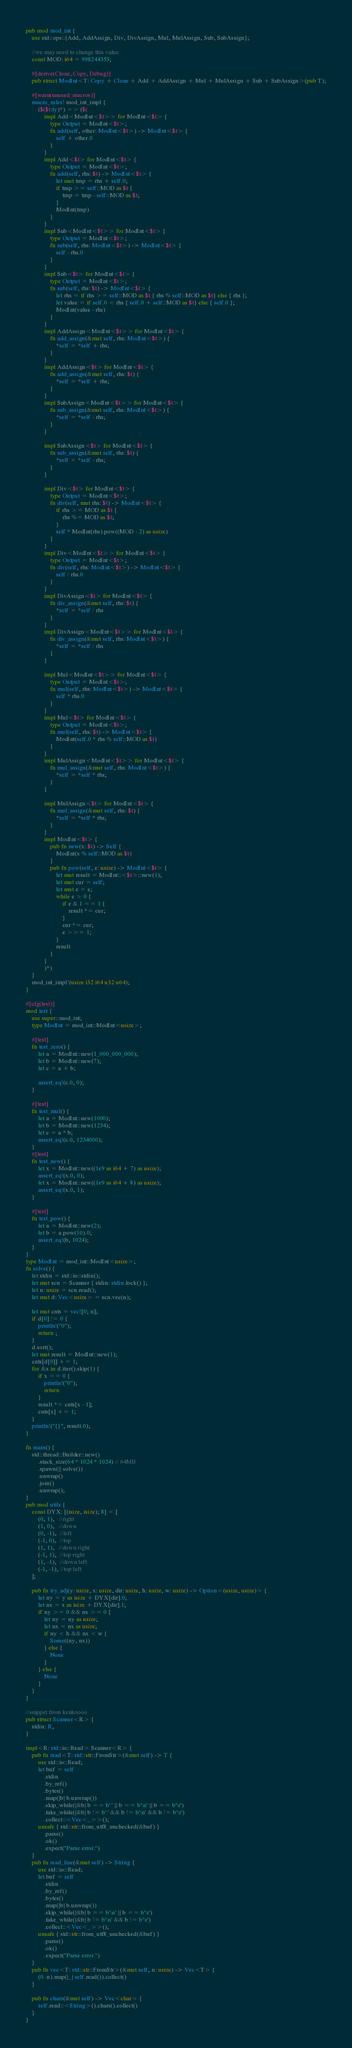<code> <loc_0><loc_0><loc_500><loc_500><_Rust_>pub mod mod_int {
    use std::ops::{Add, AddAssign, Div, DivAssign, Mul, MulAssign, Sub, SubAssign};

    //we may need to change this value
    const MOD: i64 = 998244353;

    #[derive(Clone, Copy, Debug)]
    pub struct ModInt<T: Copy + Clone + Add + AddAssign + Mul + MulAssign + Sub + SubAssign>(pub T);

    #[warn(unused_macros)]
    macro_rules! mod_int_impl {
        ($($t:ty)*) => ($(
            impl Add<ModInt<$t>> for ModInt<$t> {
                type Output = ModInt<$t>;
                fn add(self, other: ModInt<$t>) -> ModInt<$t> {
                    self + other.0
                }
            }
            impl Add<$t> for ModInt<$t> {
                type Output = ModInt<$t>;
                fn add(self, rhs: $t) -> ModInt<$t> {
                    let mut tmp = rhs + self.0;
                    if tmp >= self::MOD as $t {
                        tmp = tmp - self::MOD as $t;
                    }
                    ModInt(tmp)
                }
            }
            impl Sub<ModInt<$t>> for ModInt<$t> {
                type Output = ModInt<$t>;
                fn sub(self, rhs: ModInt<$t>) -> ModInt<$t> {
                    self - rhs.0
                }
            }
            impl Sub<$t> for ModInt<$t> {
                type Output = ModInt<$t>;
                fn sub(self, rhs: $t) -> ModInt<$t> {
                    let rhs = if rhs >= self::MOD as $t { rhs % self::MOD as $t} else { rhs };
                    let value = if self.0 < rhs { self.0 + self::MOD as $t} else { self.0 };
                    ModInt(value - rhs)
                }
            }
            impl AddAssign<ModInt<$t>> for ModInt<$t> {
                fn add_assign(&mut self, rhs: ModInt<$t>) {
                    *self = *self + rhs;
                }
            }
            impl AddAssign<$t> for ModInt<$t> {
                fn add_assign(&mut self, rhs: $t) {
                    *self = *self + rhs;
                }
            }
            impl SubAssign<ModInt<$t>> for ModInt<$t> {
                fn sub_assign(&mut self, rhs: ModInt<$t>) {
                    *self = *self - rhs;
                }
            }

            impl SubAssign<$t> for ModInt<$t> {
                fn sub_assign(&mut self, rhs: $t) {
                    *self = *self - rhs;
                }
            }

            impl Div<$t> for ModInt<$t> {
                type Output = ModInt<$t>;
                fn div(self, mut rhs: $t) -> ModInt<$t> {
                    if rhs >= MOD as $t {
                        rhs %= MOD as $t;
                    }
                    self * ModInt(rhs).pow((MOD - 2) as usize)
                }
            }
            impl Div<ModInt<$t>> for ModInt<$t> {
                type Output = ModInt<$t>;
                fn div(self, rhs: ModInt<$t>) -> ModInt<$t> {
                    self / rhs.0
                }
            }
            impl DivAssign<$t> for ModInt<$t> {
                fn div_assign(&mut self, rhs: $t) {
                    *self = *self / rhs
                }
            }
            impl DivAssign<ModInt<$t>> for ModInt<$t> {
                fn div_assign(&mut self, rhs: ModInt<$t>) {
                    *self = *self / rhs
                }
            }

            impl Mul<ModInt<$t>> for ModInt<$t> {
                type Output = ModInt<$t>;
                fn mul(self, rhs: ModInt<$t>) -> ModInt<$t> {
                    self * rhs.0
                }
            }
            impl Mul<$t> for ModInt<$t> {
                type Output = ModInt<$t>;
                fn mul(self, rhs: $t) -> ModInt<$t> {
                    ModInt(self.0 * rhs % self::MOD as $t)
                }
            }
            impl MulAssign<ModInt<$t>> for ModInt<$t> {
                fn mul_assign(&mut self, rhs: ModInt<$t>) {
                    *self = *self * rhs;
                }
            }

            impl MulAssign<$t> for ModInt<$t> {
                fn mul_assign(&mut self, rhs: $t) {
                    *self = *self * rhs;
                }
            }
            impl ModInt<$t> {
                pub fn new(x: $t) -> Self {
                    ModInt(x % self::MOD as $t)
                }
                pub fn pow(self, e: usize) -> ModInt<$t> {
                    let mut result = ModInt::<$t>::new(1);
                    let mut cur = self;
                    let mut e = e;
                    while e > 0 {
                        if e & 1 == 1 {
                            result *= cur;
                        }
                        cur *= cur;
                        e >>= 1;
                    }
                    result
                }
            }
            )*)
    }
    mod_int_impl!(usize i32 i64 u32 u64);
}

#[cfg(test)]
mod test {
    use super::mod_int;
    type ModInt = mod_int::ModInt<usize>;

    #[test]
    fn test_zero() {
        let a = ModInt::new(1_000_000_000);
        let b = ModInt::new(7);
        let c = a + b;

        assert_eq!(c.0, 0);
    }

    #[test]
    fn test_mul() {
        let a = ModInt::new(1000);
        let b = ModInt::new(1234);
        let c = a * b;
        assert_eq!(c.0, 1234000);
    }
    #[test]
    fn test_new() {
        let x = ModInt::new((1e9 as i64 + 7) as usize);
        assert_eq!(x.0, 0);
        let x = ModInt::new((1e9 as i64 + 8) as usize);
        assert_eq!(x.0, 1);
    }

    #[test]
    fn test_pow() {
        let a = ModInt::new(2);
        let b = a.pow(10).0;
        assert_eq!(b, 1024);
    }
}
type ModInt = mod_int::ModInt<usize>;
fn solve() {
    let stdin = std::io::stdin();
    let mut scn = Scanner { stdin: stdin.lock() };
    let n: usize = scn.read();
    let mut d: Vec<usize> = scn.vec(n);
    
    let mut cnts = vec![0; n];
    if d[0] != 0 {
        println!("0");
        return ;
    }
    d.sort();
    let mut result = ModInt::new(1);
    cnts[d[0]] += 1;
    for &x in d.iter().skip(1) {
        if x == 0 {
            println!("0");
            return 
        }
        result *= cnts[x - 1];
        cnts[x] += 1;
    }
    println!("{}", result.0);
}

fn main() {
    std::thread::Builder::new()
        .stack_size(64 * 1024 * 1024) // 64MB
        .spawn(|| solve())
        .unwrap()
        .join()
        .unwrap();
}
pub mod utils {
    const DYX: [(isize, isize); 8] = [
        (0, 1),   //right
        (1, 0),   //down
        (0, -1),  //left
        (-1, 0),  //top
        (1, 1),   //down right
        (-1, 1),  //top right
        (1, -1),  //down left
        (-1, -1), //top left
    ];

    pub fn try_adj(y: usize, x: usize, dir: usize, h: usize, w: usize) -> Option<(usize, usize)> {
        let ny = y as isize + DYX[dir].0;
        let nx = x as isize + DYX[dir].1;
        if ny >= 0 && nx >= 0 {
            let ny = ny as usize;
            let nx = nx as usize;
            if ny < h && nx < w {
                Some((ny, nx))
            } else {
                None
            }
        } else {
            None
        }
    }
}

//snippet from kenkoooo
pub struct Scanner<R> {
    stdin: R,
}

impl<R: std::io::Read> Scanner<R> {
    pub fn read<T: std::str::FromStr>(&mut self) -> T {
        use std::io::Read;
        let buf = self
            .stdin
            .by_ref()
            .bytes()
            .map(|b| b.unwrap())
            .skip_while(|&b| b == b' ' || b == b'\n' || b == b'\r')
            .take_while(|&b| b != b' ' && b != b'\n' && b != b'\r')
            .collect::<Vec<_>>();
        unsafe { std::str::from_utf8_unchecked(&buf) }
            .parse()
            .ok()
            .expect("Parse error.")
    }
    pub fn read_line(&mut self) -> String {
        use std::io::Read;
        let buf = self
            .stdin
            .by_ref()
            .bytes()
            .map(|b| b.unwrap())
            .skip_while(|&b| b == b'\n' || b == b'\r')
            .take_while(|&b| b != b'\n' && b != b'\r')
            .collect::<Vec<_>>();
        unsafe { std::str::from_utf8_unchecked(&buf) }
            .parse()
            .ok()
            .expect("Parse error.")
    }
    pub fn vec<T: std::str::FromStr>(&mut self, n: usize) -> Vec<T> {
        (0..n).map(|_| self.read()).collect()
    }

    pub fn chars(&mut self) -> Vec<char> {
        self.read::<String>().chars().collect()
    }
}
</code> 